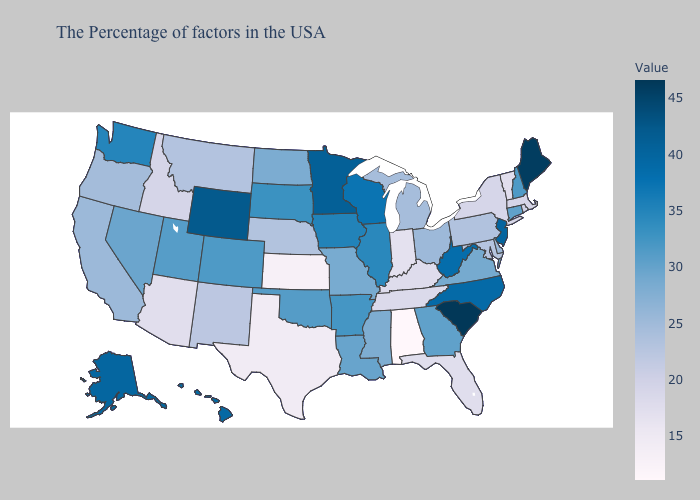Does West Virginia have a higher value than South Carolina?
Concise answer only. No. Which states have the lowest value in the West?
Keep it brief. Arizona. Which states hav the highest value in the West?
Keep it brief. Wyoming. Does Massachusetts have a higher value than Texas?
Write a very short answer. Yes. Does Arizona have a higher value than Nevada?
Keep it brief. No. 